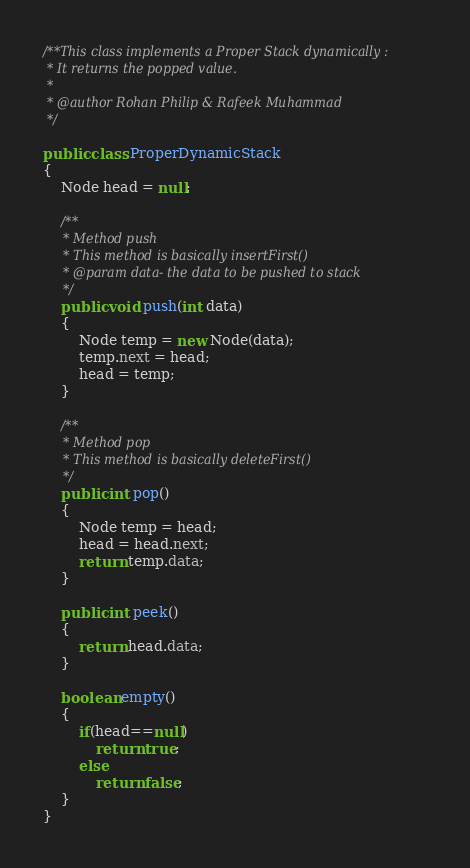Convert code to text. <code><loc_0><loc_0><loc_500><loc_500><_Java_>/**This class implements a Proper Stack dynamically :
 * It returns the popped value.
 * 
 * @author Rohan Philip & Rafeek Muhammad
 */

public class ProperDynamicStack
{
    Node head = null;

    /**
     * Method push
     * This method is basically insertFirst()
     * @param data- the data to be pushed to stack
     */
    public void push(int data)
    {
        Node temp = new Node(data);
        temp.next = head;
        head = temp;
    }

    /**
     * Method pop
     * This method is basically deleteFirst()
     */
    public int pop()
    {
        Node temp = head;
        head = head.next;
        return temp.data;
    }

    public int peek()
    {
        return head.data;
    }
    
    boolean empty()
    {
        if(head==null)
            return true;
        else
            return false;
    }
}</code> 